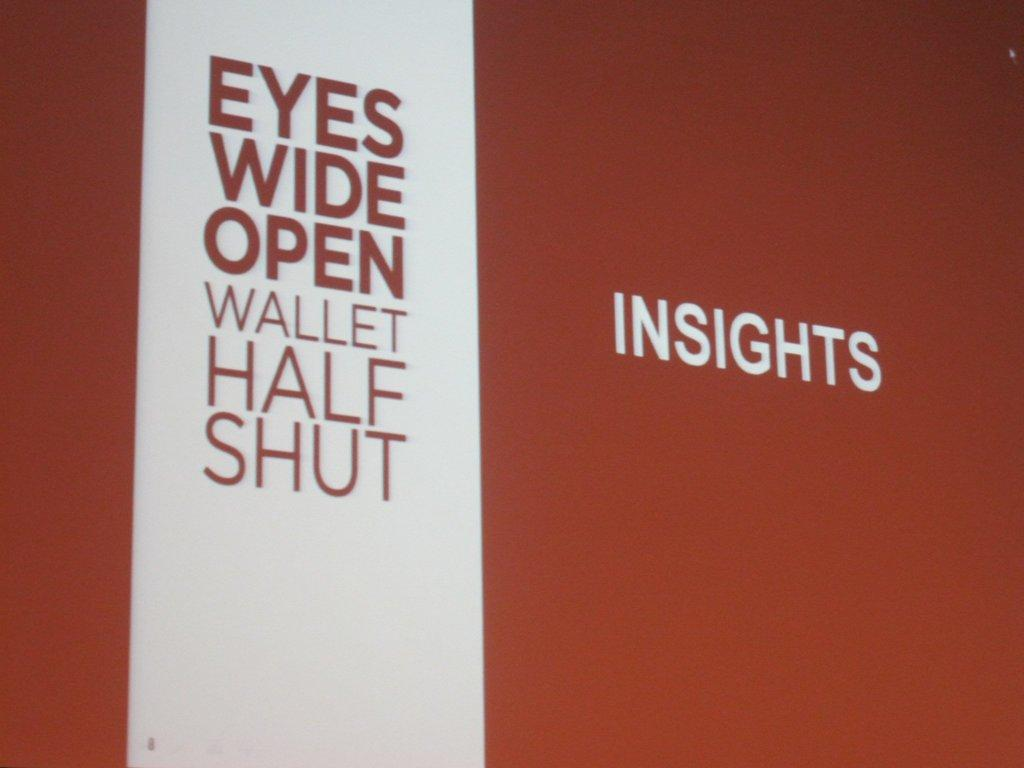<image>
Summarize the visual content of the image. A large sign on an orange background titled Insights 